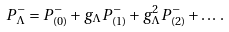<formula> <loc_0><loc_0><loc_500><loc_500>P ^ { - } _ { \Lambda } = P ^ { - } _ { ( 0 ) } + g _ { \Lambda } P ^ { - } _ { ( 1 ) } + g _ { \Lambda } ^ { 2 } P ^ { - } _ { ( 2 ) } + \dots \, .</formula> 